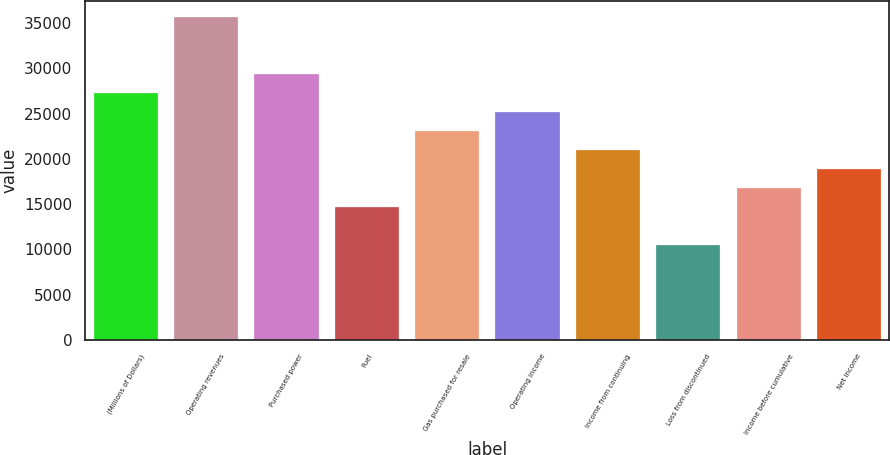Convert chart. <chart><loc_0><loc_0><loc_500><loc_500><bar_chart><fcel>(Millions of Dollars)<fcel>Operating revenues<fcel>Purchased power<fcel>Fuel<fcel>Gas purchased for resale<fcel>Operating income<fcel>Income from continuing<fcel>Loss from discontinued<fcel>Income before cumulative<fcel>Net income<nl><fcel>27255.7<fcel>35641.8<fcel>29352.2<fcel>14676.4<fcel>23062.5<fcel>25159.1<fcel>20966<fcel>10483.2<fcel>16772.9<fcel>18869.5<nl></chart> 